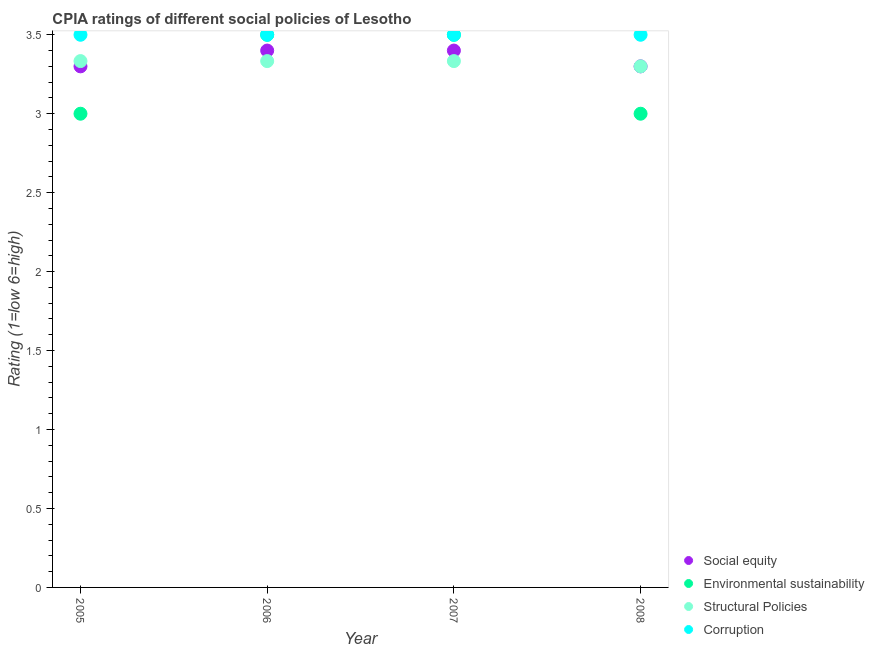How many different coloured dotlines are there?
Your answer should be very brief. 4. What is the cpia rating of environmental sustainability in 2006?
Your answer should be compact. 3.5. What is the total cpia rating of structural policies in the graph?
Your answer should be compact. 13.3. What is the difference between the cpia rating of social equity in 2006 and that in 2008?
Make the answer very short. 0.1. What is the difference between the cpia rating of corruption in 2007 and the cpia rating of environmental sustainability in 2005?
Give a very brief answer. 0.5. What is the average cpia rating of structural policies per year?
Ensure brevity in your answer.  3.32. In the year 2006, what is the difference between the cpia rating of corruption and cpia rating of structural policies?
Make the answer very short. 0.17. In how many years, is the cpia rating of environmental sustainability greater than 1.6?
Ensure brevity in your answer.  4. What is the ratio of the cpia rating of environmental sustainability in 2006 to that in 2008?
Your response must be concise. 1.17. What is the difference between the highest and the second highest cpia rating of corruption?
Ensure brevity in your answer.  0. What is the difference between the highest and the lowest cpia rating of structural policies?
Provide a short and direct response. 0.03. What is the difference between two consecutive major ticks on the Y-axis?
Ensure brevity in your answer.  0.5. Does the graph contain any zero values?
Your answer should be very brief. No. Where does the legend appear in the graph?
Your answer should be compact. Bottom right. How are the legend labels stacked?
Your answer should be compact. Vertical. What is the title of the graph?
Your answer should be compact. CPIA ratings of different social policies of Lesotho. Does "Energy" appear as one of the legend labels in the graph?
Give a very brief answer. No. What is the label or title of the X-axis?
Keep it short and to the point. Year. What is the label or title of the Y-axis?
Provide a short and direct response. Rating (1=low 6=high). What is the Rating (1=low 6=high) in Social equity in 2005?
Your answer should be very brief. 3.3. What is the Rating (1=low 6=high) in Structural Policies in 2005?
Your answer should be compact. 3.33. What is the Rating (1=low 6=high) in Corruption in 2005?
Make the answer very short. 3.5. What is the Rating (1=low 6=high) of Structural Policies in 2006?
Provide a succinct answer. 3.33. What is the Rating (1=low 6=high) in Corruption in 2006?
Give a very brief answer. 3.5. What is the Rating (1=low 6=high) of Environmental sustainability in 2007?
Make the answer very short. 3.5. What is the Rating (1=low 6=high) in Structural Policies in 2007?
Keep it short and to the point. 3.33. What is the Rating (1=low 6=high) in Social equity in 2008?
Your response must be concise. 3.3. Across all years, what is the maximum Rating (1=low 6=high) in Structural Policies?
Provide a short and direct response. 3.33. Across all years, what is the minimum Rating (1=low 6=high) in Structural Policies?
Give a very brief answer. 3.3. Across all years, what is the minimum Rating (1=low 6=high) of Corruption?
Your answer should be very brief. 3.5. What is the total Rating (1=low 6=high) of Social equity in the graph?
Provide a short and direct response. 13.4. What is the total Rating (1=low 6=high) in Structural Policies in the graph?
Your response must be concise. 13.3. What is the total Rating (1=low 6=high) of Corruption in the graph?
Offer a terse response. 14. What is the difference between the Rating (1=low 6=high) in Social equity in 2005 and that in 2006?
Keep it short and to the point. -0.1. What is the difference between the Rating (1=low 6=high) in Environmental sustainability in 2005 and that in 2006?
Your answer should be very brief. -0.5. What is the difference between the Rating (1=low 6=high) of Environmental sustainability in 2005 and that in 2007?
Give a very brief answer. -0.5. What is the difference between the Rating (1=low 6=high) in Structural Policies in 2005 and that in 2007?
Offer a very short reply. 0. What is the difference between the Rating (1=low 6=high) in Corruption in 2005 and that in 2007?
Ensure brevity in your answer.  0. What is the difference between the Rating (1=low 6=high) in Social equity in 2005 and that in 2008?
Provide a short and direct response. 0. What is the difference between the Rating (1=low 6=high) in Corruption in 2005 and that in 2008?
Give a very brief answer. 0. What is the difference between the Rating (1=low 6=high) of Corruption in 2006 and that in 2007?
Give a very brief answer. 0. What is the difference between the Rating (1=low 6=high) of Social equity in 2006 and that in 2008?
Your answer should be compact. 0.1. What is the difference between the Rating (1=low 6=high) in Environmental sustainability in 2006 and that in 2008?
Provide a short and direct response. 0.5. What is the difference between the Rating (1=low 6=high) in Structural Policies in 2006 and that in 2008?
Provide a short and direct response. 0.03. What is the difference between the Rating (1=low 6=high) in Corruption in 2006 and that in 2008?
Offer a very short reply. 0. What is the difference between the Rating (1=low 6=high) in Social equity in 2007 and that in 2008?
Keep it short and to the point. 0.1. What is the difference between the Rating (1=low 6=high) in Environmental sustainability in 2007 and that in 2008?
Give a very brief answer. 0.5. What is the difference between the Rating (1=low 6=high) in Social equity in 2005 and the Rating (1=low 6=high) in Structural Policies in 2006?
Keep it short and to the point. -0.03. What is the difference between the Rating (1=low 6=high) in Social equity in 2005 and the Rating (1=low 6=high) in Corruption in 2006?
Your answer should be very brief. -0.2. What is the difference between the Rating (1=low 6=high) in Environmental sustainability in 2005 and the Rating (1=low 6=high) in Corruption in 2006?
Provide a succinct answer. -0.5. What is the difference between the Rating (1=low 6=high) of Structural Policies in 2005 and the Rating (1=low 6=high) of Corruption in 2006?
Offer a terse response. -0.17. What is the difference between the Rating (1=low 6=high) in Social equity in 2005 and the Rating (1=low 6=high) in Structural Policies in 2007?
Make the answer very short. -0.03. What is the difference between the Rating (1=low 6=high) in Environmental sustainability in 2005 and the Rating (1=low 6=high) in Structural Policies in 2007?
Offer a terse response. -0.33. What is the difference between the Rating (1=low 6=high) of Structural Policies in 2005 and the Rating (1=low 6=high) of Corruption in 2007?
Ensure brevity in your answer.  -0.17. What is the difference between the Rating (1=low 6=high) in Social equity in 2005 and the Rating (1=low 6=high) in Environmental sustainability in 2008?
Offer a very short reply. 0.3. What is the difference between the Rating (1=low 6=high) in Social equity in 2005 and the Rating (1=low 6=high) in Structural Policies in 2008?
Provide a succinct answer. 0. What is the difference between the Rating (1=low 6=high) in Environmental sustainability in 2005 and the Rating (1=low 6=high) in Corruption in 2008?
Offer a terse response. -0.5. What is the difference between the Rating (1=low 6=high) in Social equity in 2006 and the Rating (1=low 6=high) in Structural Policies in 2007?
Give a very brief answer. 0.07. What is the difference between the Rating (1=low 6=high) of Environmental sustainability in 2006 and the Rating (1=low 6=high) of Structural Policies in 2007?
Your response must be concise. 0.17. What is the difference between the Rating (1=low 6=high) of Social equity in 2006 and the Rating (1=low 6=high) of Environmental sustainability in 2008?
Provide a short and direct response. 0.4. What is the difference between the Rating (1=low 6=high) of Social equity in 2006 and the Rating (1=low 6=high) of Structural Policies in 2008?
Offer a terse response. 0.1. What is the difference between the Rating (1=low 6=high) in Social equity in 2006 and the Rating (1=low 6=high) in Corruption in 2008?
Make the answer very short. -0.1. What is the difference between the Rating (1=low 6=high) of Environmental sustainability in 2006 and the Rating (1=low 6=high) of Structural Policies in 2008?
Offer a very short reply. 0.2. What is the difference between the Rating (1=low 6=high) in Environmental sustainability in 2006 and the Rating (1=low 6=high) in Corruption in 2008?
Your answer should be very brief. 0. What is the difference between the Rating (1=low 6=high) in Social equity in 2007 and the Rating (1=low 6=high) in Structural Policies in 2008?
Provide a succinct answer. 0.1. What is the difference between the Rating (1=low 6=high) in Environmental sustainability in 2007 and the Rating (1=low 6=high) in Structural Policies in 2008?
Your response must be concise. 0.2. What is the average Rating (1=low 6=high) in Social equity per year?
Give a very brief answer. 3.35. What is the average Rating (1=low 6=high) of Structural Policies per year?
Your response must be concise. 3.33. In the year 2005, what is the difference between the Rating (1=low 6=high) in Social equity and Rating (1=low 6=high) in Structural Policies?
Your answer should be compact. -0.03. In the year 2005, what is the difference between the Rating (1=low 6=high) of Social equity and Rating (1=low 6=high) of Corruption?
Make the answer very short. -0.2. In the year 2005, what is the difference between the Rating (1=low 6=high) of Environmental sustainability and Rating (1=low 6=high) of Structural Policies?
Your answer should be compact. -0.33. In the year 2005, what is the difference between the Rating (1=low 6=high) in Environmental sustainability and Rating (1=low 6=high) in Corruption?
Offer a terse response. -0.5. In the year 2006, what is the difference between the Rating (1=low 6=high) of Social equity and Rating (1=low 6=high) of Structural Policies?
Your response must be concise. 0.07. In the year 2006, what is the difference between the Rating (1=low 6=high) of Environmental sustainability and Rating (1=low 6=high) of Corruption?
Provide a short and direct response. 0. In the year 2006, what is the difference between the Rating (1=low 6=high) of Structural Policies and Rating (1=low 6=high) of Corruption?
Keep it short and to the point. -0.17. In the year 2007, what is the difference between the Rating (1=low 6=high) of Social equity and Rating (1=low 6=high) of Environmental sustainability?
Offer a very short reply. -0.1. In the year 2007, what is the difference between the Rating (1=low 6=high) in Social equity and Rating (1=low 6=high) in Structural Policies?
Your response must be concise. 0.07. In the year 2008, what is the difference between the Rating (1=low 6=high) of Social equity and Rating (1=low 6=high) of Environmental sustainability?
Provide a short and direct response. 0.3. In the year 2008, what is the difference between the Rating (1=low 6=high) of Social equity and Rating (1=low 6=high) of Structural Policies?
Offer a terse response. 0. In the year 2008, what is the difference between the Rating (1=low 6=high) in Social equity and Rating (1=low 6=high) in Corruption?
Make the answer very short. -0.2. In the year 2008, what is the difference between the Rating (1=low 6=high) of Environmental sustainability and Rating (1=low 6=high) of Corruption?
Offer a terse response. -0.5. In the year 2008, what is the difference between the Rating (1=low 6=high) of Structural Policies and Rating (1=low 6=high) of Corruption?
Keep it short and to the point. -0.2. What is the ratio of the Rating (1=low 6=high) of Social equity in 2005 to that in 2006?
Your answer should be compact. 0.97. What is the ratio of the Rating (1=low 6=high) in Structural Policies in 2005 to that in 2006?
Offer a terse response. 1. What is the ratio of the Rating (1=low 6=high) in Social equity in 2005 to that in 2007?
Your answer should be very brief. 0.97. What is the ratio of the Rating (1=low 6=high) in Environmental sustainability in 2005 to that in 2007?
Provide a short and direct response. 0.86. What is the ratio of the Rating (1=low 6=high) of Social equity in 2005 to that in 2008?
Keep it short and to the point. 1. What is the ratio of the Rating (1=low 6=high) in Environmental sustainability in 2005 to that in 2008?
Give a very brief answer. 1. What is the ratio of the Rating (1=low 6=high) of Corruption in 2005 to that in 2008?
Provide a succinct answer. 1. What is the ratio of the Rating (1=low 6=high) in Environmental sustainability in 2006 to that in 2007?
Ensure brevity in your answer.  1. What is the ratio of the Rating (1=low 6=high) in Structural Policies in 2006 to that in 2007?
Your answer should be compact. 1. What is the ratio of the Rating (1=low 6=high) in Social equity in 2006 to that in 2008?
Keep it short and to the point. 1.03. What is the ratio of the Rating (1=low 6=high) in Structural Policies in 2006 to that in 2008?
Your answer should be compact. 1.01. What is the ratio of the Rating (1=low 6=high) of Social equity in 2007 to that in 2008?
Your answer should be very brief. 1.03. What is the ratio of the Rating (1=low 6=high) in Structural Policies in 2007 to that in 2008?
Your answer should be compact. 1.01. What is the difference between the highest and the second highest Rating (1=low 6=high) of Social equity?
Ensure brevity in your answer.  0. What is the difference between the highest and the second highest Rating (1=low 6=high) of Environmental sustainability?
Provide a succinct answer. 0. What is the difference between the highest and the second highest Rating (1=low 6=high) in Corruption?
Your response must be concise. 0. 